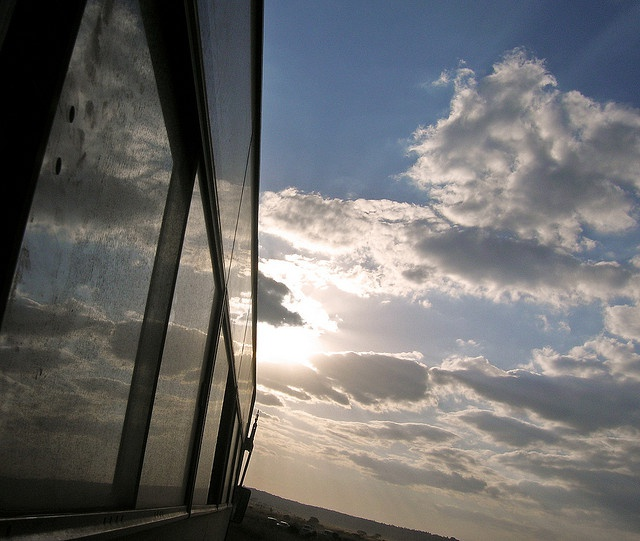Describe the objects in this image and their specific colors. I can see bus in black, gray, and darkgray tones in this image. 